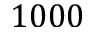<formula> <loc_0><loc_0><loc_500><loc_500>1 0 0 0</formula> 